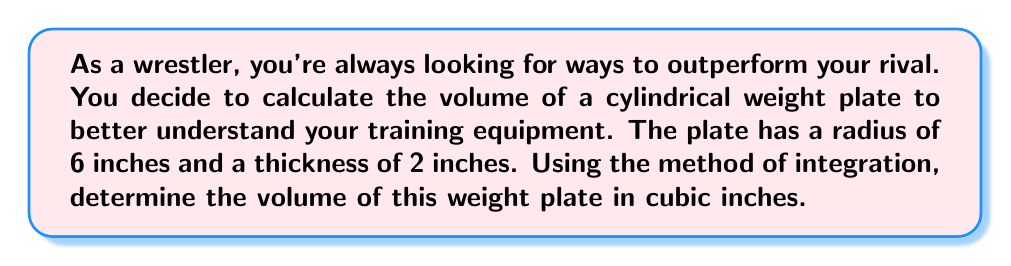Solve this math problem. Let's approach this step-by-step using integration:

1) A cylinder can be thought of as a stack of circular disks. We'll integrate the area of these disks over the height of the cylinder.

2) The volume of a cylinder is given by the integral:

   $$V = \int_0^h \pi r^2 dh$$

   Where $r$ is the radius and $h$ is the height (thickness) of the cylinder.

3) In this case, $r = 6$ inches and $h = 2$ inches.

4) Substituting these values:

   $$V = \int_0^2 \pi (6^2) dh$$

5) Simplify the constant under the integral:

   $$V = \int_0^2 36\pi dh$$

6) Integrate:

   $$V = 36\pi h \bigg|_0^2$$

7) Evaluate the integral:

   $$V = 36\pi(2) - 36\pi(0) = 72\pi$$

8) Therefore, the volume is $72\pi$ cubic inches.

[asy]
import geometry;

size(200);
path p = circle((0,0),6);
path q = circle((0,20),6);
draw(p);
draw(q);
draw((6,0)--(6,20));
draw((-6,0)--(-6,20));
label("6 in", (7,10), E);
label("2 in", (0,22), N);
</asy]
Answer: $72\pi$ cubic inches 